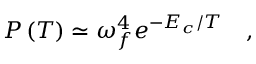<formula> <loc_0><loc_0><loc_500><loc_500>P \left ( T \right ) \simeq \omega _ { f } ^ { 4 } e ^ { - E _ { c } / T } \quad ,</formula> 